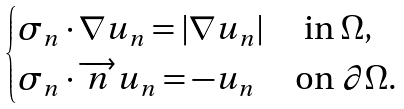Convert formula to latex. <formula><loc_0><loc_0><loc_500><loc_500>\begin{cases} \sigma _ { n } \cdot \nabla u _ { n } = | \nabla u _ { n } | \ \quad \text {in} \ \Omega , \\ \sigma _ { n } \cdot \overrightarrow { n } u _ { n } = - u _ { n } \ \quad \text {on} \ \partial \Omega . \end{cases}</formula> 